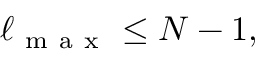<formula> <loc_0><loc_0><loc_500><loc_500>\begin{array} { r } { \ell _ { m a x } \leq N - 1 , } \end{array}</formula> 